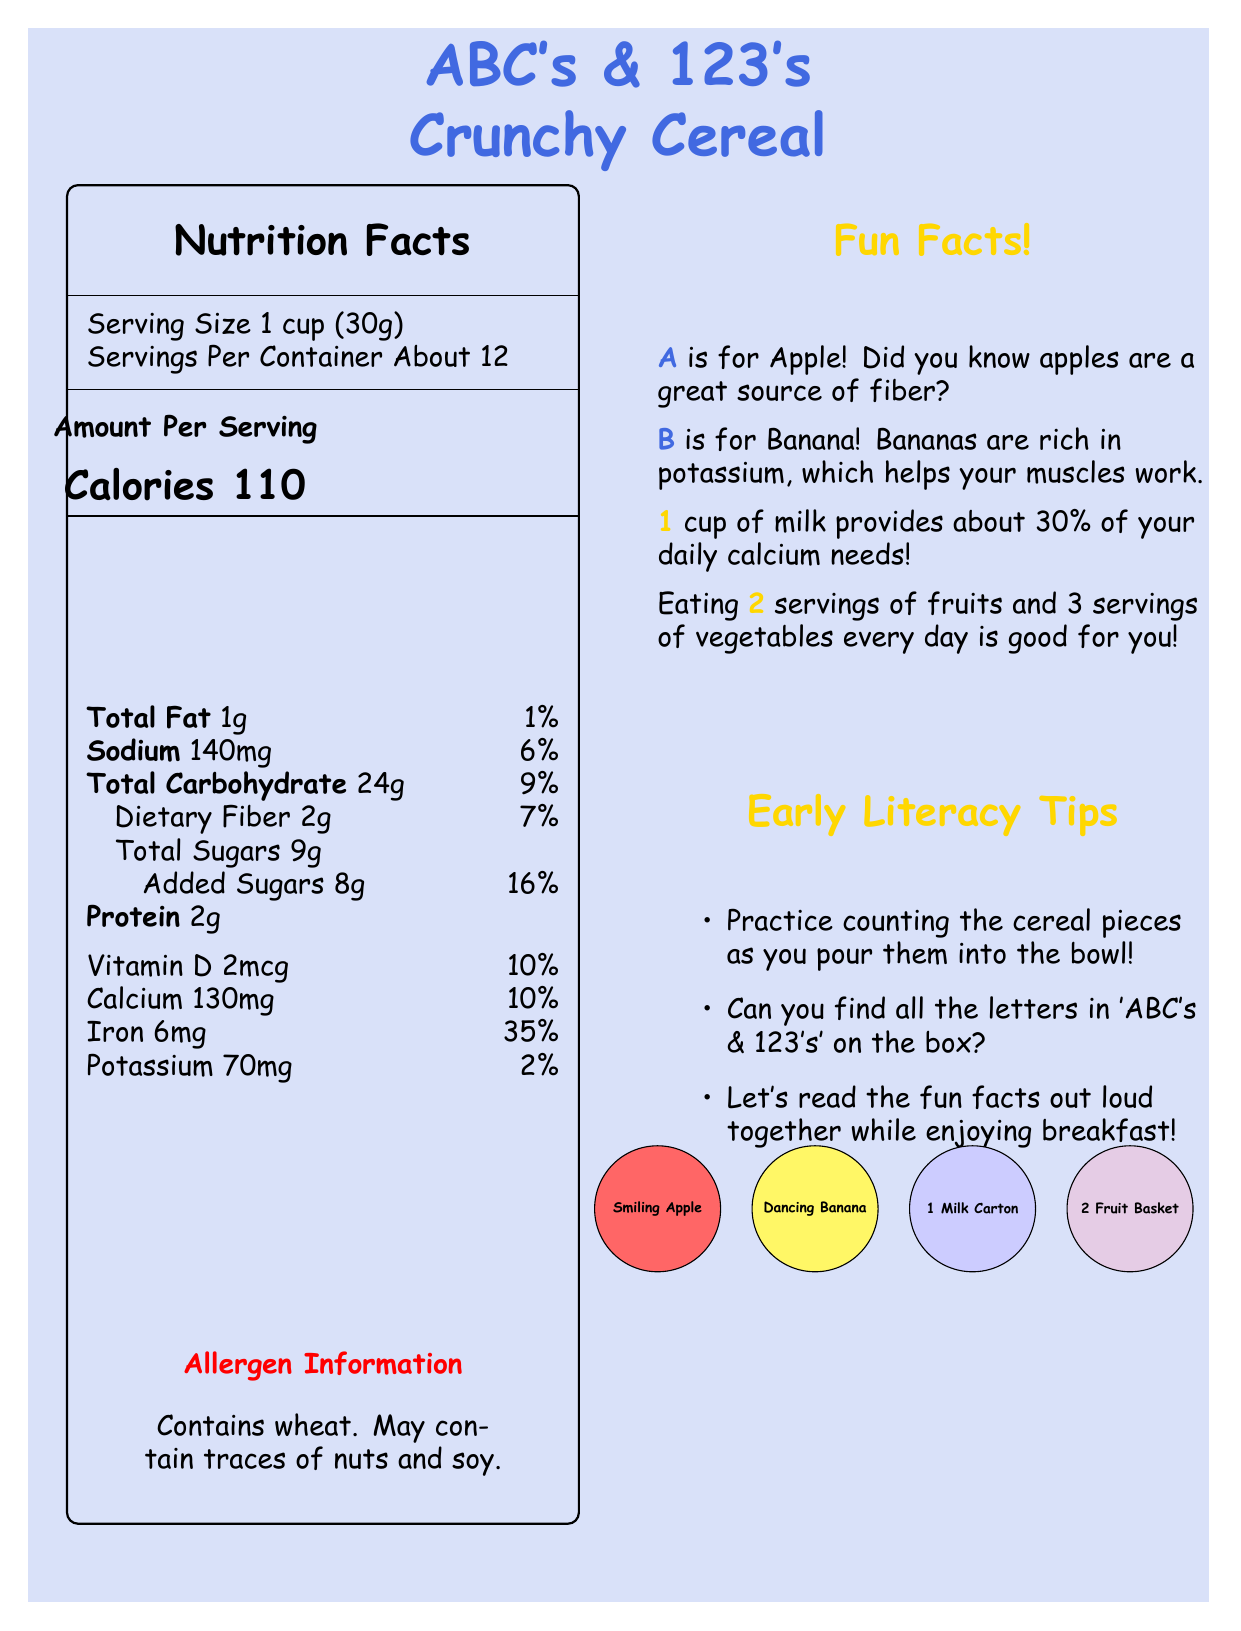what is the serving size of ABC's & 123's Crunchy Cereal? The serving size is clearly listed as "1 cup (30g)" on the Nutrition Facts label.
Answer: 1 cup (30g) how many servings are there per container? According to the Nutrition Facts label, there are about 12 servings per container.
Answer: About 12 how many calories are in one serving of the cereal? The label indicates that each serving contains 110 calories.
Answer: 110 what is the percentage of Daily Value for iron per serving? The Nutrition Facts label lists the iron content as having a 35% Daily Value per serving.
Answer: 35% how much dietary fiber does one serving contain? One serving contains 2 grams of dietary fiber, as listed on the Nutrition Facts.
Answer: 2g what is the total carbohydrate content per serving of the cereal? A. 15g B. 20g C. 24g D. 30g The Nutrition Facts label states that each serving has 24 grams of total carbohydrates.
Answer: C which of the following nutrients has the highest percent Daily Value in one serving? A. Iron B. Sodium C. Vitamin D D. Calcium Iron has the highest daily value at 35%, compared to sodium (6%), Vitamin D (10%), and Calcium (10%).
Answer: A is the cereal a good source of vitamins and minerals? The Nutrition Facts label shows that the cereal provides significant percentages of daily values for several vitamins and minerals, such as iron (35%), Vitamin D (10%), and Calcium (10%).
Answer: Yes what is the main idea of this document? It describes the nutritional content, serving size, educational elements about letters and numbers, allergen potential, and interactive tips to encourage early literacy.
Answer: The document provides nutritional information, educational facts, early literacy tips, allergen information, and colorful graphics for a popular children's cereal called ABC's & 123's Crunchy Cereal. what is the dietary fiber daily value percentage? The document states that one serving contributes 7% to the daily value of dietary fiber.
Answer: 7% what is the allergen information mentioned on the box? The allergen information is given under the "Allergen Information" section, specifying that it contains wheat and may have traces of nuts and soy.
Answer: Contains wheat. May contain traces of nuts and soy. how many grams of protein are in one serving? The label specifies that one serving contains 2 grams of protein.
Answer: 2g what does "A" stand for in the educational facts? The educational fact states "A is for Apple! Did you know apples are a great source of fiber?"
Answer: Apple what can you do while enjoying breakfast according to the early literacy tips? The tips suggest counting the cereal pieces, finding letters, and reading the fun facts out loud.
Answer: Practice counting the cereal pieces, find all the letters in 'ABC's & 123's' on the box, and read the fun facts out loud together. how many colorful graphics are mentioned and what are they? The document mentions 4 colorful graphics with their descriptions.
Answer: 4: smiling apple, dancing banana, number 1 with milk carton, number 2 with fruit basket does the cereal contain added sugars? The Nutrition Facts label indicates that there are 8 grams of added sugars per serving.
Answer: Yes what are the natural flavors included in the ingredients list? The document does not provide specifics about what the natural flavors are, only that they are part of the ingredients.
Answer: Cannot be determined 